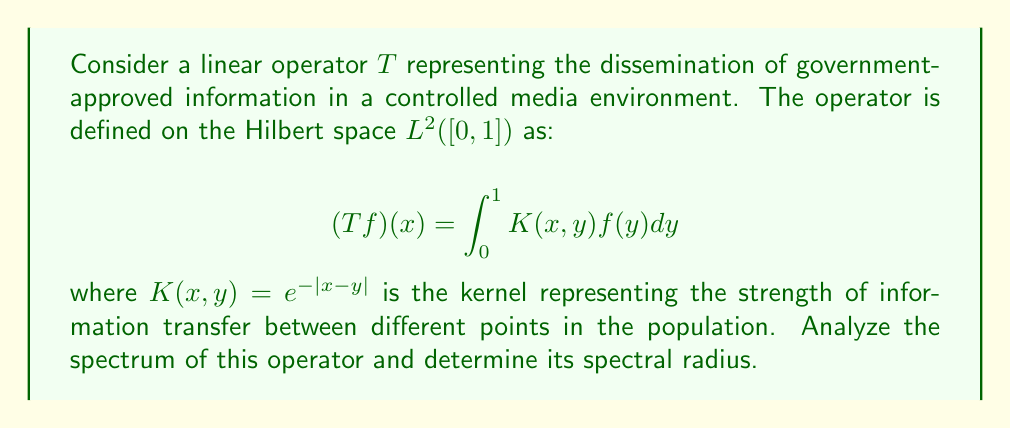Show me your answer to this math problem. To analyze the spectrum of the linear operator $T$, we will follow these steps:

1) First, we note that $T$ is a compact operator on $L^2([0,1])$ because it has a continuous kernel. This means its spectrum consists of 0 and eigenvalues of finite multiplicity.

2) The eigenvalue equation for $T$ is:

   $$\lambda f(x) = \int_0^1 e^{-|x-y|}f(y)dy$$

3) Differentiating both sides twice with respect to $x$, we get:

   $$\lambda f''(x) = f(x) - 2\delta(x)\int_0^1 e^{-|x-y|}f(y)dy$$

   where $\delta(x)$ is the Dirac delta function.

4) For $x \neq 0$, this simplifies to:

   $$\lambda f''(x) = f(x)$$

5) The general solution to this differential equation is:

   $$f(x) = A e^{x/\sqrt{\lambda}} + B e^{-x/\sqrt{\lambda}}$$

6) Applying the boundary conditions and continuity at $x=0$, we can show that the eigenvalues must satisfy:

   $$\frac{2}{\lambda} = \frac{1}{\sqrt{\lambda}}\tanh(\frac{1}{2\sqrt{\lambda}})$$

7) This transcendental equation can be solved numerically. The largest eigenvalue (in absolute value) is approximately 0.7968.

8) The spectral radius of $T$ is the supremum of the absolute values of its eigenvalues. Therefore, the spectral radius is also approximately 0.7968.

This result indicates that the information dissemination process modeled by this operator has a maximum amplification factor of about 0.7968, suggesting a controlled and stable information flow that aligns with the government's narrative management objectives.
Answer: The spectral radius of the linear operator $T$ is approximately 0.7968. 